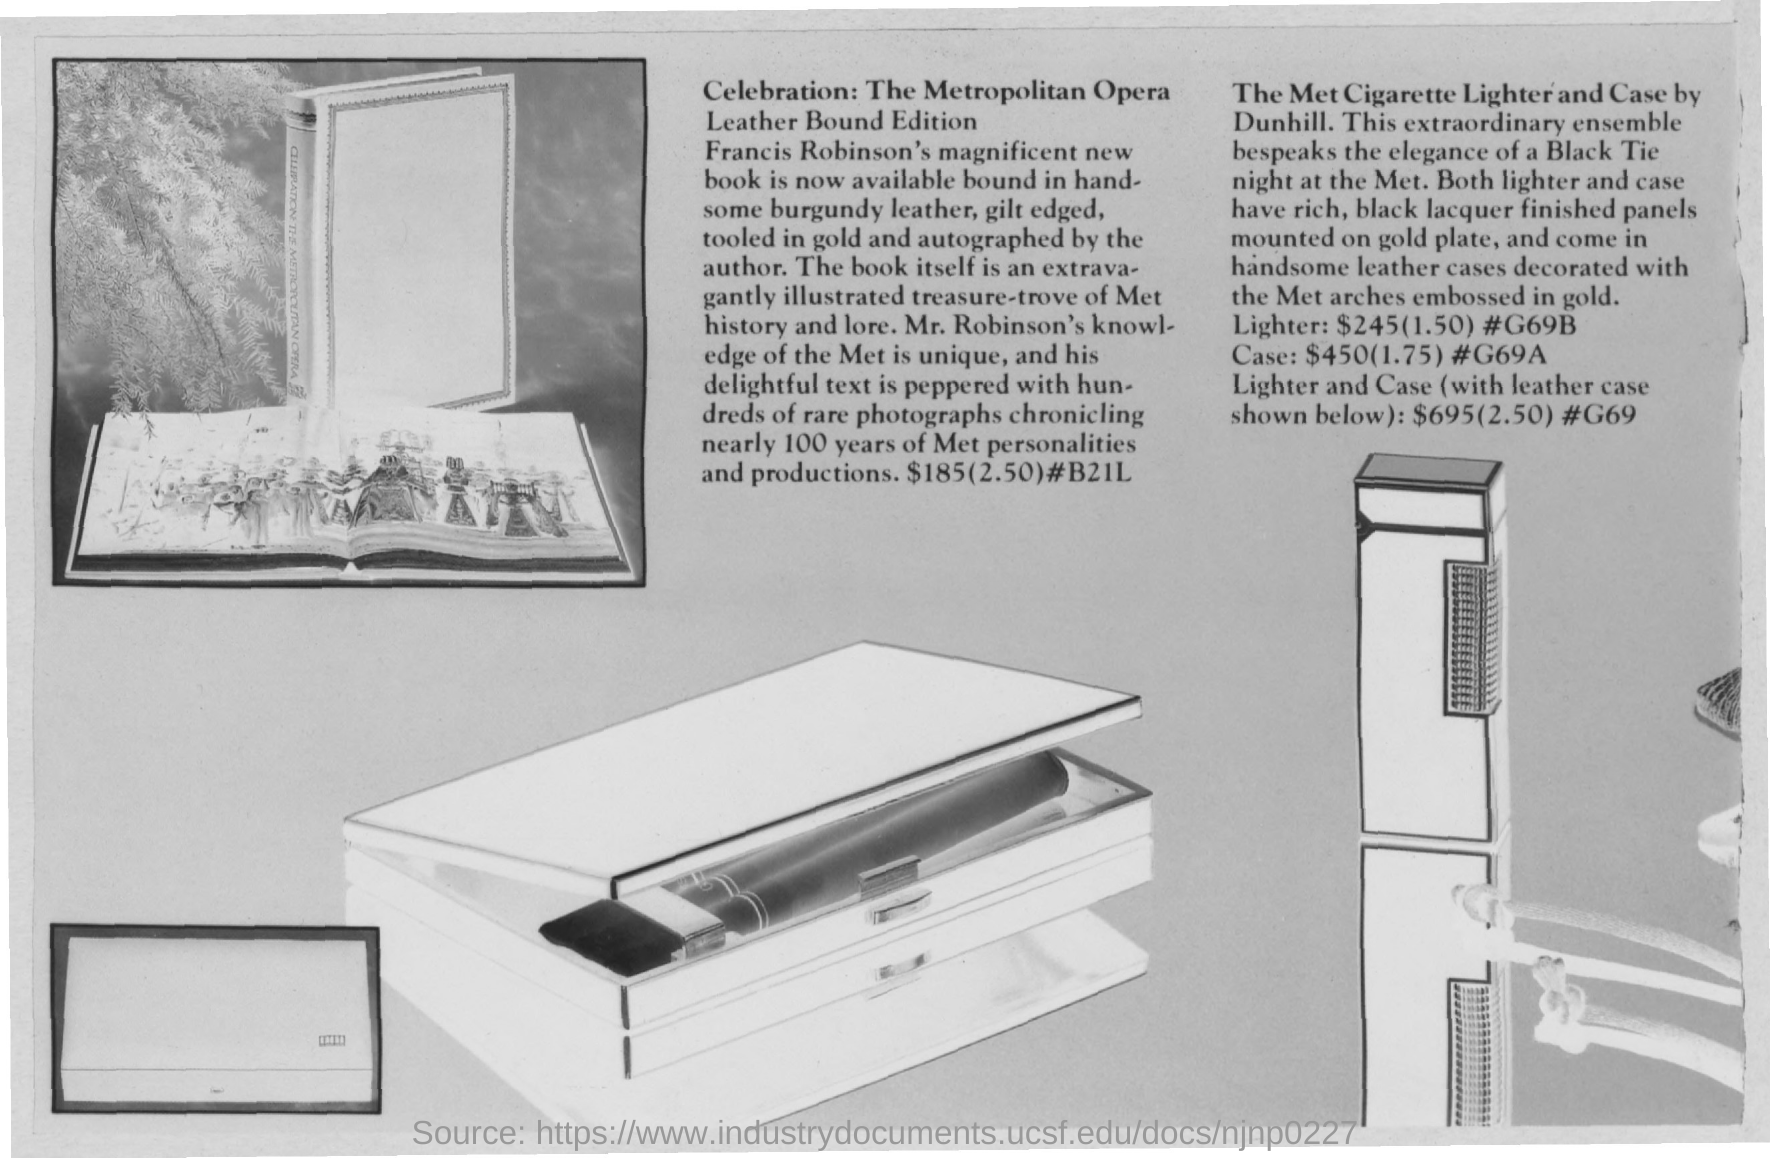Whose book is now available bound in leather?
Offer a very short reply. Francis robinson's. What is the price of the metropolitan opera leather bound edition?
Make the answer very short. $185. What is the price of the met cigarette lighter?
Make the answer very short. $245. What is the price of the met cigarette case?
Give a very brief answer. $450. What is the price of the met cigarette case and lighter?
Offer a terse response. $695. 